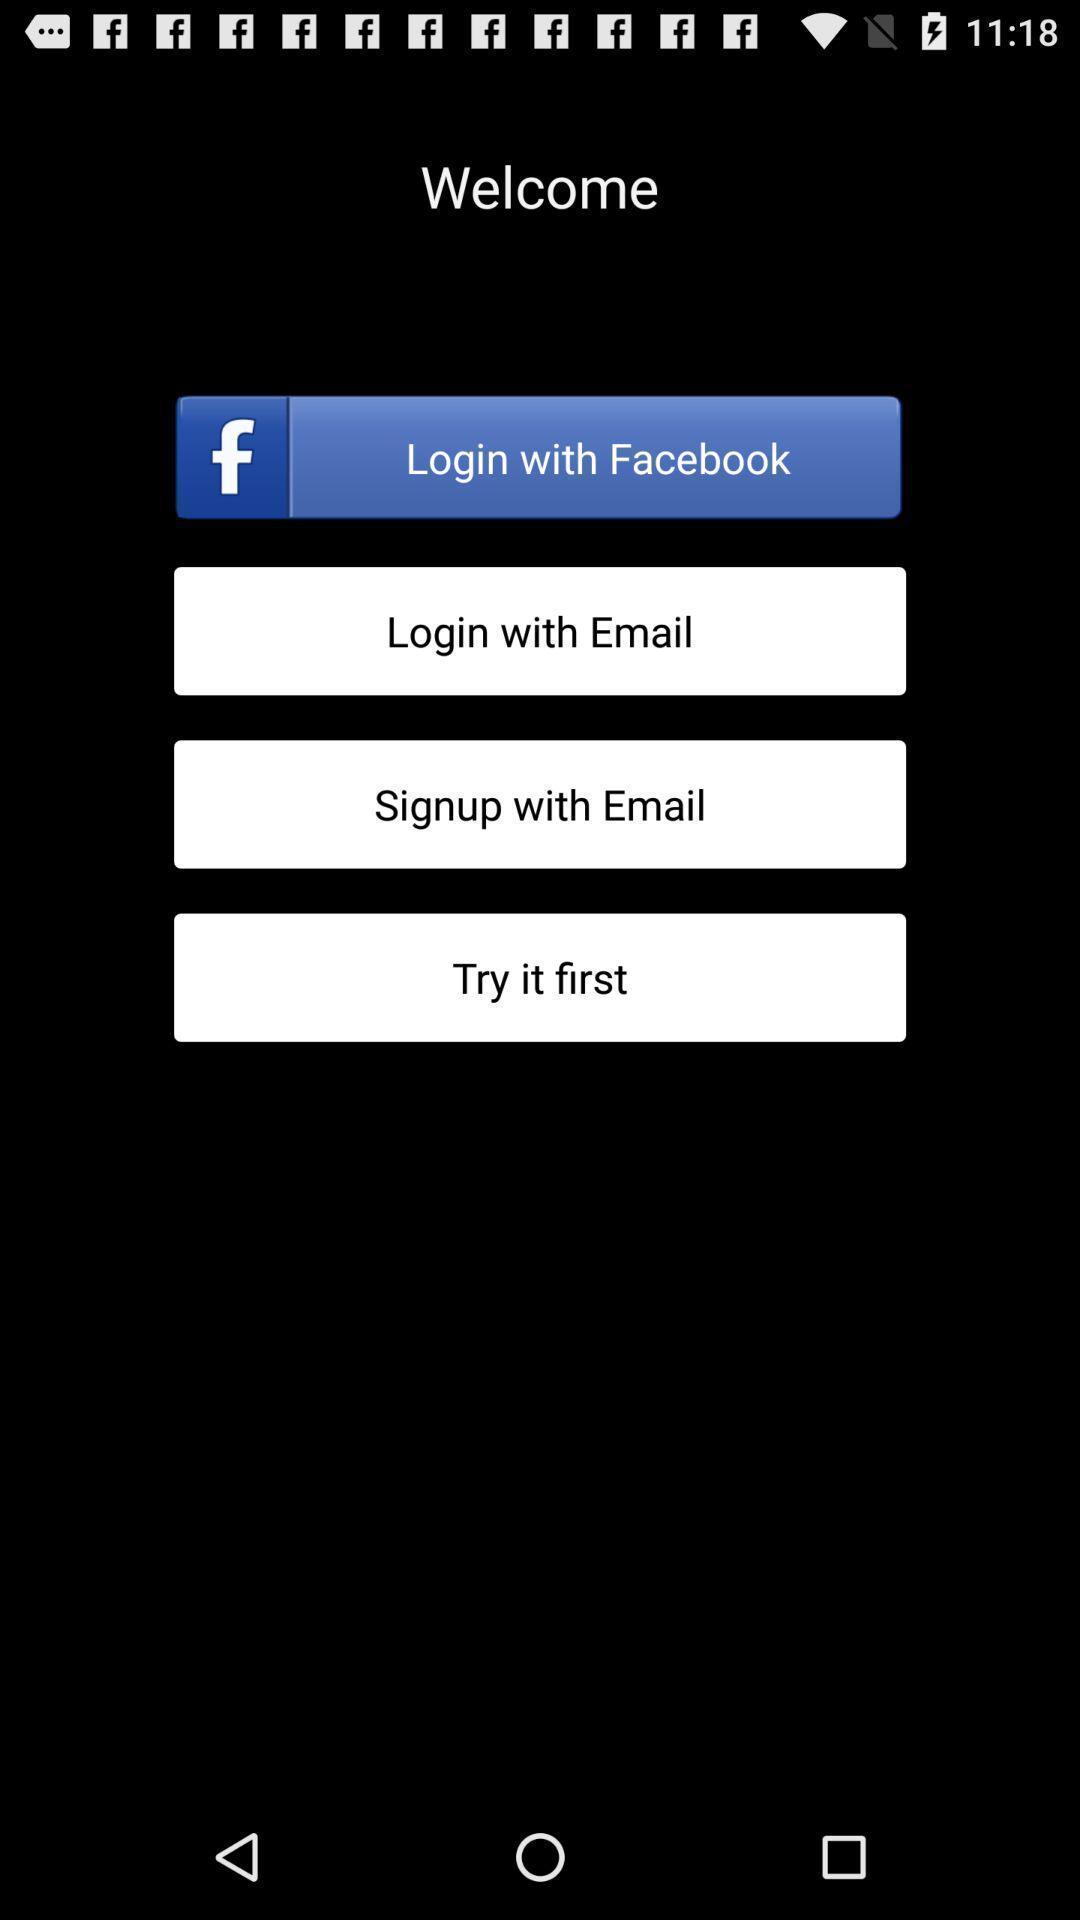Give me a narrative description of this picture. Welcome page of language learning application with log in option. 